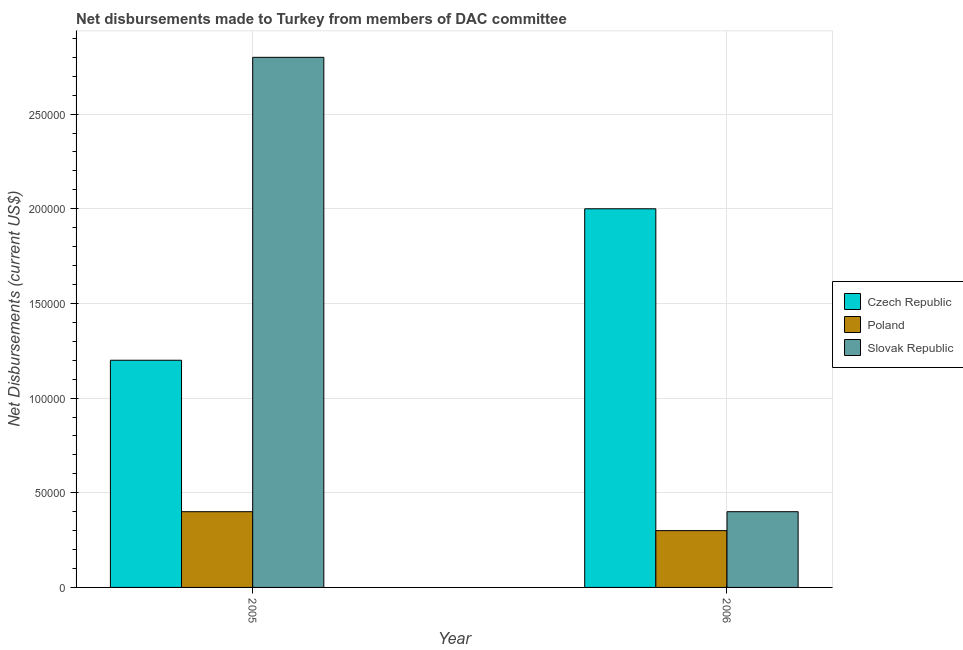How many different coloured bars are there?
Offer a very short reply. 3. Are the number of bars on each tick of the X-axis equal?
Keep it short and to the point. Yes. How many bars are there on the 1st tick from the left?
Your response must be concise. 3. What is the label of the 2nd group of bars from the left?
Keep it short and to the point. 2006. What is the net disbursements made by slovak republic in 2006?
Your answer should be compact. 4.00e+04. Across all years, what is the maximum net disbursements made by slovak republic?
Provide a short and direct response. 2.80e+05. Across all years, what is the minimum net disbursements made by poland?
Your answer should be very brief. 3.00e+04. What is the total net disbursements made by slovak republic in the graph?
Your answer should be compact. 3.20e+05. What is the difference between the net disbursements made by poland in 2005 and that in 2006?
Provide a short and direct response. 10000. What is the difference between the net disbursements made by czech republic in 2006 and the net disbursements made by slovak republic in 2005?
Keep it short and to the point. 8.00e+04. What is the average net disbursements made by slovak republic per year?
Make the answer very short. 1.60e+05. In the year 2006, what is the difference between the net disbursements made by czech republic and net disbursements made by poland?
Your answer should be very brief. 0. In how many years, is the net disbursements made by czech republic greater than 50000 US$?
Your answer should be compact. 2. What is the ratio of the net disbursements made by slovak republic in 2005 to that in 2006?
Ensure brevity in your answer.  7. What does the 3rd bar from the left in 2006 represents?
Your answer should be very brief. Slovak Republic. What does the 2nd bar from the right in 2005 represents?
Ensure brevity in your answer.  Poland. How many bars are there?
Your answer should be compact. 6. How many years are there in the graph?
Your answer should be very brief. 2. What is the difference between two consecutive major ticks on the Y-axis?
Offer a terse response. 5.00e+04. Does the graph contain any zero values?
Offer a terse response. No. How many legend labels are there?
Your answer should be very brief. 3. How are the legend labels stacked?
Provide a succinct answer. Vertical. What is the title of the graph?
Your response must be concise. Net disbursements made to Turkey from members of DAC committee. What is the label or title of the X-axis?
Provide a succinct answer. Year. What is the label or title of the Y-axis?
Make the answer very short. Net Disbursements (current US$). What is the Net Disbursements (current US$) in Czech Republic in 2006?
Make the answer very short. 2.00e+05. What is the Net Disbursements (current US$) in Slovak Republic in 2006?
Your answer should be very brief. 4.00e+04. Across all years, what is the maximum Net Disbursements (current US$) in Czech Republic?
Offer a very short reply. 2.00e+05. Across all years, what is the maximum Net Disbursements (current US$) of Slovak Republic?
Provide a succinct answer. 2.80e+05. Across all years, what is the minimum Net Disbursements (current US$) of Czech Republic?
Your answer should be compact. 1.20e+05. Across all years, what is the minimum Net Disbursements (current US$) of Slovak Republic?
Offer a terse response. 4.00e+04. What is the total Net Disbursements (current US$) of Czech Republic in the graph?
Your answer should be very brief. 3.20e+05. What is the total Net Disbursements (current US$) in Poland in the graph?
Your answer should be very brief. 7.00e+04. What is the total Net Disbursements (current US$) in Slovak Republic in the graph?
Your answer should be compact. 3.20e+05. What is the difference between the Net Disbursements (current US$) of Slovak Republic in 2005 and that in 2006?
Your response must be concise. 2.40e+05. What is the difference between the Net Disbursements (current US$) of Czech Republic in 2005 and the Net Disbursements (current US$) of Poland in 2006?
Offer a very short reply. 9.00e+04. What is the difference between the Net Disbursements (current US$) of Czech Republic in 2005 and the Net Disbursements (current US$) of Slovak Republic in 2006?
Your answer should be very brief. 8.00e+04. What is the difference between the Net Disbursements (current US$) in Poland in 2005 and the Net Disbursements (current US$) in Slovak Republic in 2006?
Offer a terse response. 0. What is the average Net Disbursements (current US$) in Poland per year?
Make the answer very short. 3.50e+04. What is the average Net Disbursements (current US$) in Slovak Republic per year?
Make the answer very short. 1.60e+05. In the year 2005, what is the difference between the Net Disbursements (current US$) of Czech Republic and Net Disbursements (current US$) of Poland?
Your answer should be very brief. 8.00e+04. In the year 2005, what is the difference between the Net Disbursements (current US$) of Czech Republic and Net Disbursements (current US$) of Slovak Republic?
Make the answer very short. -1.60e+05. In the year 2005, what is the difference between the Net Disbursements (current US$) of Poland and Net Disbursements (current US$) of Slovak Republic?
Your response must be concise. -2.40e+05. In the year 2006, what is the difference between the Net Disbursements (current US$) of Czech Republic and Net Disbursements (current US$) of Poland?
Your answer should be compact. 1.70e+05. What is the ratio of the Net Disbursements (current US$) in Slovak Republic in 2005 to that in 2006?
Ensure brevity in your answer.  7. What is the difference between the highest and the lowest Net Disbursements (current US$) in Czech Republic?
Ensure brevity in your answer.  8.00e+04. What is the difference between the highest and the lowest Net Disbursements (current US$) of Poland?
Provide a short and direct response. 10000. 